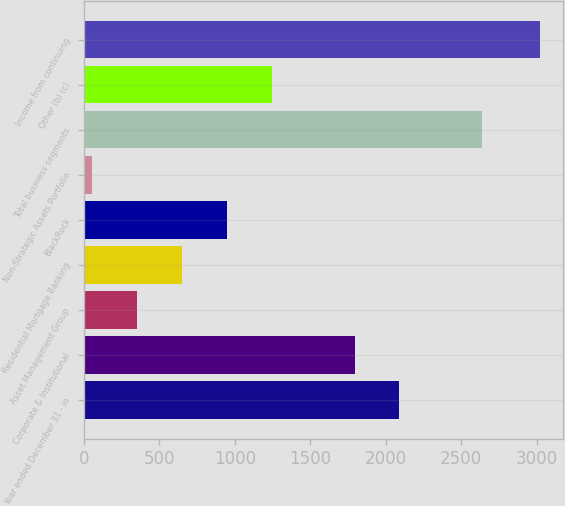Convert chart to OTSL. <chart><loc_0><loc_0><loc_500><loc_500><bar_chart><fcel>Year ended December 31 - in<fcel>Corporate & Institutional<fcel>Asset Management Group<fcel>Residential Mortgage Banking<fcel>BlackRock<fcel>Non-Strategic Assets Portfolio<fcel>Total business segments<fcel>Other (b) (c)<fcel>Income from continuing<nl><fcel>2090.7<fcel>1794<fcel>353.7<fcel>650.4<fcel>947.1<fcel>57<fcel>2638<fcel>1243.8<fcel>3024<nl></chart> 